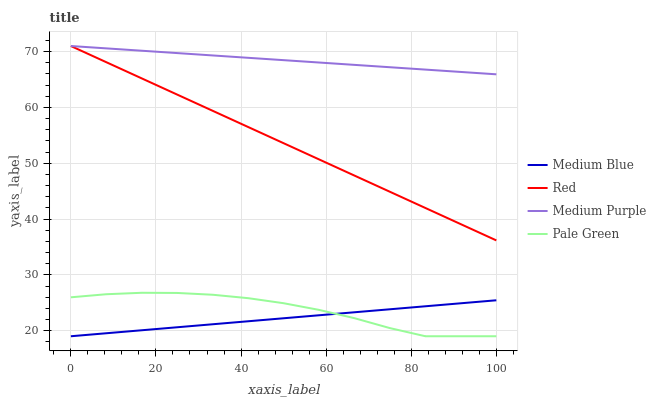Does Medium Blue have the minimum area under the curve?
Answer yes or no. Yes. Does Medium Purple have the maximum area under the curve?
Answer yes or no. Yes. Does Pale Green have the minimum area under the curve?
Answer yes or no. No. Does Pale Green have the maximum area under the curve?
Answer yes or no. No. Is Medium Blue the smoothest?
Answer yes or no. Yes. Is Pale Green the roughest?
Answer yes or no. Yes. Is Pale Green the smoothest?
Answer yes or no. No. Is Medium Blue the roughest?
Answer yes or no. No. Does Pale Green have the lowest value?
Answer yes or no. Yes. Does Red have the lowest value?
Answer yes or no. No. Does Red have the highest value?
Answer yes or no. Yes. Does Pale Green have the highest value?
Answer yes or no. No. Is Medium Blue less than Medium Purple?
Answer yes or no. Yes. Is Red greater than Pale Green?
Answer yes or no. Yes. Does Pale Green intersect Medium Blue?
Answer yes or no. Yes. Is Pale Green less than Medium Blue?
Answer yes or no. No. Is Pale Green greater than Medium Blue?
Answer yes or no. No. Does Medium Blue intersect Medium Purple?
Answer yes or no. No. 